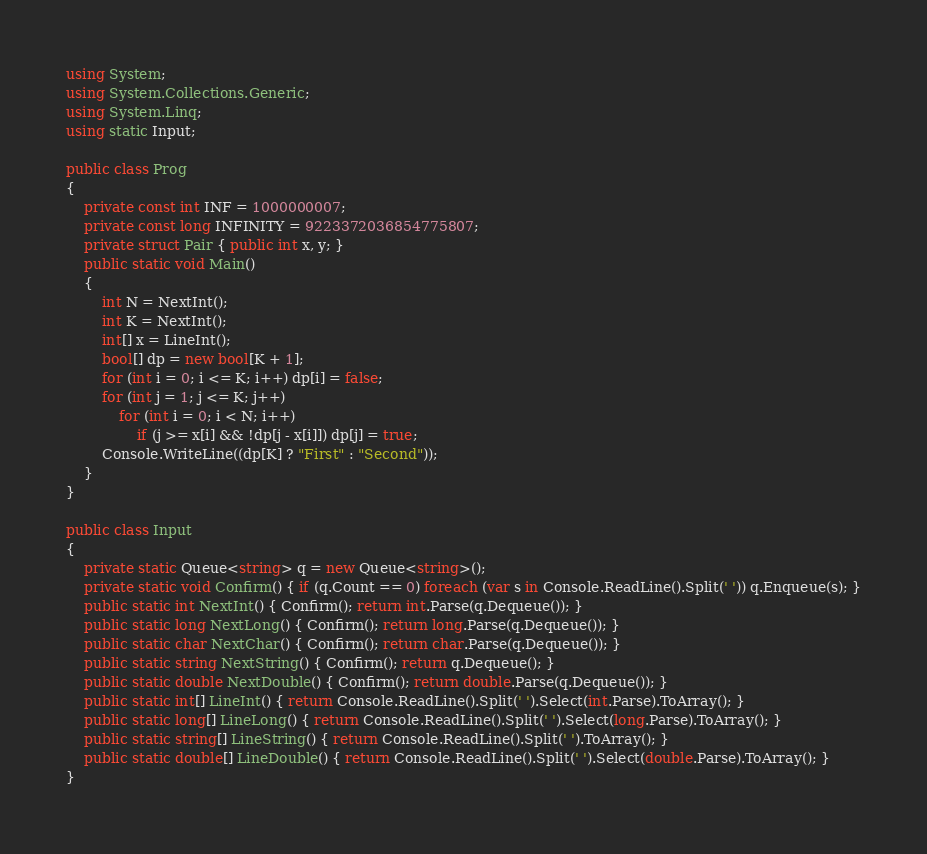<code> <loc_0><loc_0><loc_500><loc_500><_C#_>using System;
using System.Collections.Generic;
using System.Linq;
using static Input;

public class Prog
{
    private const int INF = 1000000007;
    private const long INFINITY = 9223372036854775807;
    private struct Pair { public int x, y; }
    public static void Main()
    {
        int N = NextInt();
        int K = NextInt();
        int[] x = LineInt();
        bool[] dp = new bool[K + 1];
        for (int i = 0; i <= K; i++) dp[i] = false;
        for (int j = 1; j <= K; j++)
            for (int i = 0; i < N; i++)
                if (j >= x[i] && !dp[j - x[i]]) dp[j] = true;
        Console.WriteLine((dp[K] ? "First" : "Second"));
    }
}

public class Input
{
    private static Queue<string> q = new Queue<string>();
    private static void Confirm() { if (q.Count == 0) foreach (var s in Console.ReadLine().Split(' ')) q.Enqueue(s); }
    public static int NextInt() { Confirm(); return int.Parse(q.Dequeue()); }
    public static long NextLong() { Confirm(); return long.Parse(q.Dequeue()); }
    public static char NextChar() { Confirm(); return char.Parse(q.Dequeue()); }
    public static string NextString() { Confirm(); return q.Dequeue(); }
    public static double NextDouble() { Confirm(); return double.Parse(q.Dequeue()); }
    public static int[] LineInt() { return Console.ReadLine().Split(' ').Select(int.Parse).ToArray(); }
    public static long[] LineLong() { return Console.ReadLine().Split(' ').Select(long.Parse).ToArray(); }
    public static string[] LineString() { return Console.ReadLine().Split(' ').ToArray(); }
    public static double[] LineDouble() { return Console.ReadLine().Split(' ').Select(double.Parse).ToArray(); }
}
</code> 